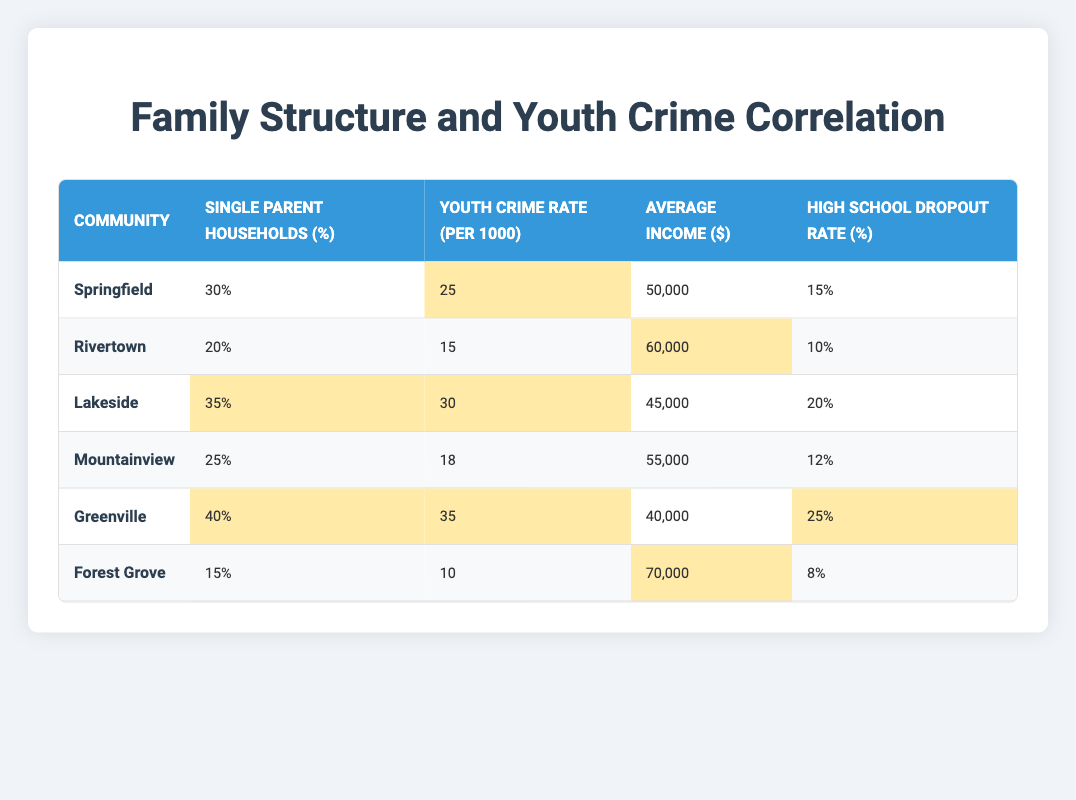What is the youth crime rate in Greenville? The table shows that the youth crime rate in Greenville is listed as 35 per 1000.
Answer: 35 What percentage of single-parent households is in Lakeside? According to the table, Lakeside has 35% of single-parent households.
Answer: 35% Which community has the highest average income? By checking the average income column, Forest Grove has the highest average income at $70,000.
Answer: $70,000 What is the difference in youth crime rates between Springfield and Forest Grove? Springfield's youth crime rate is 25 per 1000, while Forest Grove's is 10 per 1000. The difference is 25 - 10 = 15.
Answer: 15 Is it true that Rivertown has a higher youth crime rate than Mountainview? Rivertown has a youth crime rate of 15 per 1000 and Mountainview has a rate of 18 per 1000. Therefore, Rivertown does not have a higher youth crime rate than Mountainview.
Answer: No What is the average high school dropout rate across all communities? To find the average dropout rate, we sum the dropout rates: 15 + 10 + 20 + 12 + 25 + 8 = 90. Then, we divide by the number of communities (6): 90 / 6 = 15%.
Answer: 15% Which community shows the strongest correlation between a high percentage of single-parent households and youth crime rates? By examining the table, we see Greenville has 40% single-parent households and a youth crime rate of 35, while Lakeside has 35% and a rate of 30. Greenville exhibits the strongest correlation.
Answer: Greenville How many communities have a single-parent household percentage above 30%? The communities with percentages above 30% are Springfield (30%), Lakeside (35%), and Greenville (40%). This gives us a total of 3 communities.
Answer: 3 What is the median youth crime rate among the communities? To find the median, we first arrange the youth crime rates: 10, 15, 18, 25, 30, 35. With 6 entries, the median is the average of 18 and 25: (18 + 25) / 2 = 21.5.
Answer: 21.5 